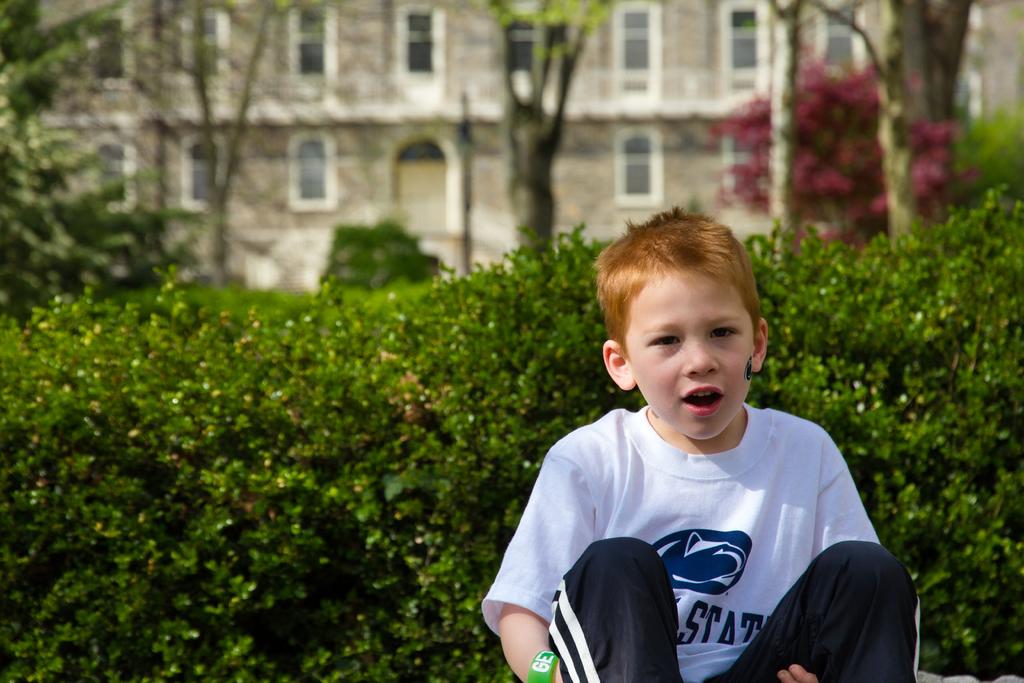What does his shirt say?
Ensure brevity in your answer.  State. 